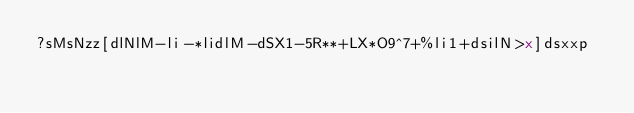<code> <loc_0><loc_0><loc_500><loc_500><_dc_>?sMsNzz[dlNlM-li-*lidlM-dSX1-5R**+LX*O9^7+%li1+dsilN>x]dsxxp</code> 